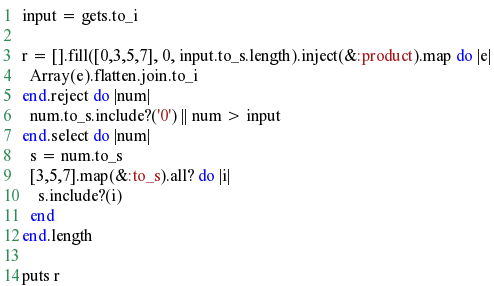Convert code to text. <code><loc_0><loc_0><loc_500><loc_500><_Ruby_>input = gets.to_i

r = [].fill([0,3,5,7], 0, input.to_s.length).inject(&:product).map do |e|
  Array(e).flatten.join.to_i
end.reject do |num|
  num.to_s.include?('0') || num > input
end.select do |num|
  s = num.to_s
  [3,5,7].map(&:to_s).all? do |i|
    s.include?(i)
  end
end.length

puts r
</code> 